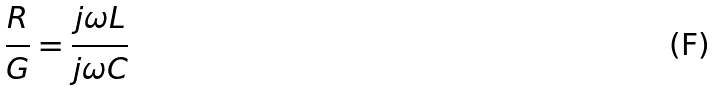<formula> <loc_0><loc_0><loc_500><loc_500>\frac { R } { G } = \frac { j \omega L } { j \omega C }</formula> 